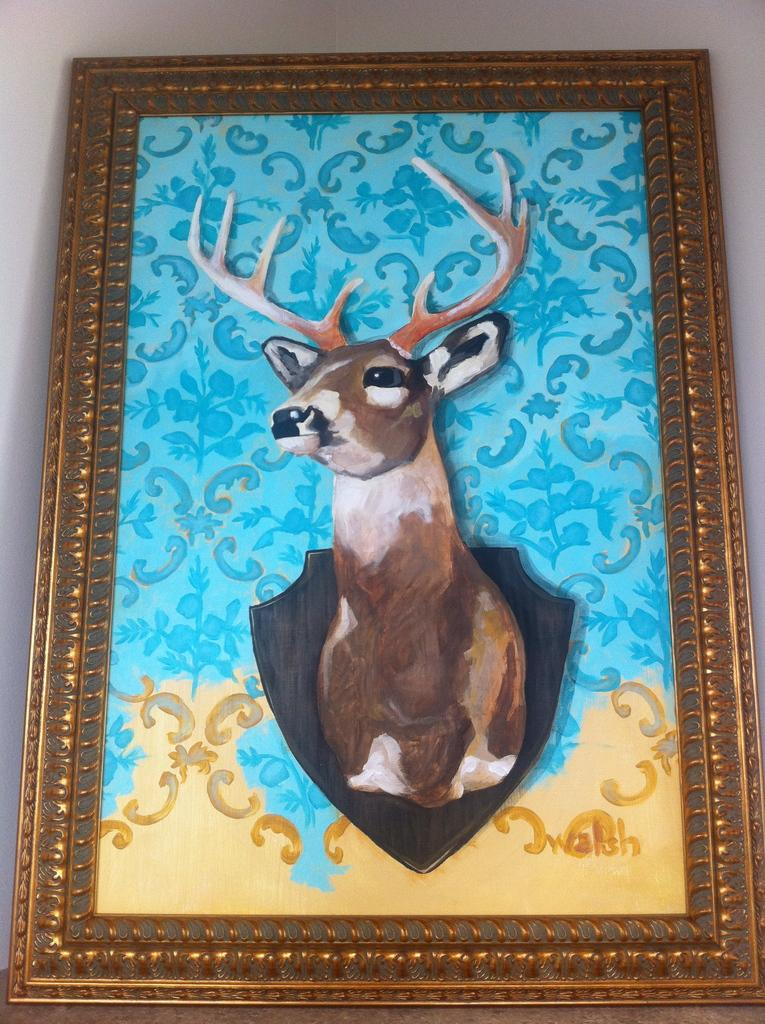What is the main subject of the painting in the image? The painting contains a deer. What can be seen in the background of the painting? There is a wall in the background of the painting. What is the object that frames the painting in the image? There is a frame of a painting in the image. What is the name of the daughter of the deer in the painting? There is no daughter of the deer in the painting, as it is a painting of a deer and not a family portrait. 